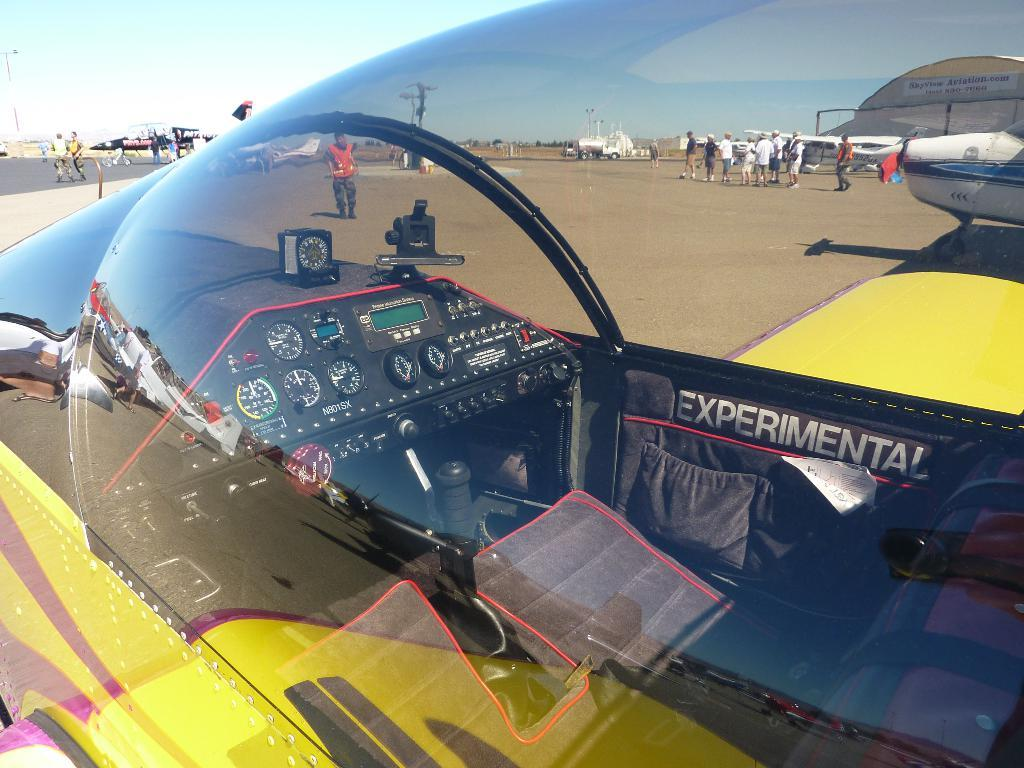What is the main subject of the image? The main subject of the image is planes. Can you describe the people in the image? There is a group of people in the image. What else can be seen in the image besides planes and people? There are vehicles and a current pole in the image. What is visible at the top of the image? The sky is visible at the top of the image. What type of hope can be seen in the image? There is no hope present in the image; it features planes, a group of people, vehicles, a current pole, and the sky. What substance is being used by the people in the image to rest? There is no indication in the image that the people are resting or using any substance for that purpose. 